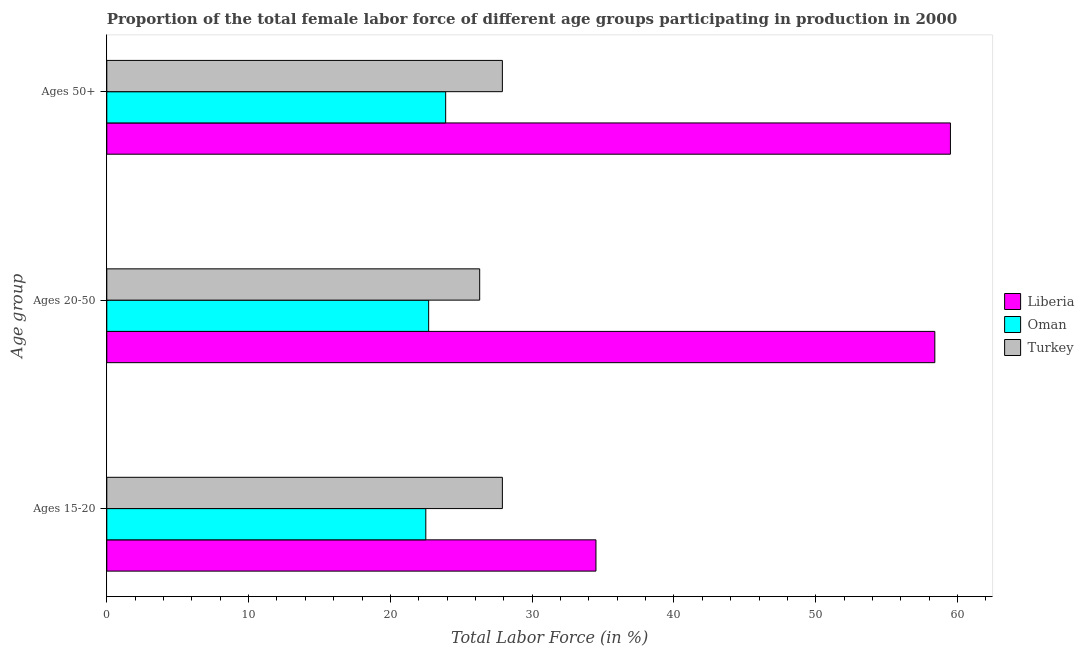How many bars are there on the 3rd tick from the top?
Keep it short and to the point. 3. How many bars are there on the 1st tick from the bottom?
Provide a succinct answer. 3. What is the label of the 3rd group of bars from the top?
Make the answer very short. Ages 15-20. What is the percentage of female labor force within the age group 15-20 in Turkey?
Your answer should be very brief. 27.9. Across all countries, what is the maximum percentage of female labor force within the age group 20-50?
Provide a short and direct response. 58.4. Across all countries, what is the minimum percentage of female labor force above age 50?
Your response must be concise. 23.9. In which country was the percentage of female labor force within the age group 15-20 maximum?
Your response must be concise. Liberia. In which country was the percentage of female labor force above age 50 minimum?
Provide a short and direct response. Oman. What is the total percentage of female labor force above age 50 in the graph?
Ensure brevity in your answer.  111.3. What is the difference between the percentage of female labor force above age 50 in Oman and that in Liberia?
Provide a short and direct response. -35.6. What is the difference between the percentage of female labor force above age 50 in Liberia and the percentage of female labor force within the age group 15-20 in Turkey?
Make the answer very short. 31.6. What is the average percentage of female labor force above age 50 per country?
Offer a terse response. 37.1. What is the difference between the percentage of female labor force above age 50 and percentage of female labor force within the age group 20-50 in Liberia?
Give a very brief answer. 1.1. In how many countries, is the percentage of female labor force within the age group 15-20 greater than 40 %?
Give a very brief answer. 0. What is the ratio of the percentage of female labor force within the age group 15-20 in Liberia to that in Oman?
Provide a succinct answer. 1.53. What is the difference between the highest and the second highest percentage of female labor force above age 50?
Provide a succinct answer. 31.6. What is the difference between the highest and the lowest percentage of female labor force above age 50?
Provide a succinct answer. 35.6. Is the sum of the percentage of female labor force within the age group 15-20 in Turkey and Oman greater than the maximum percentage of female labor force above age 50 across all countries?
Keep it short and to the point. No. What does the 1st bar from the top in Ages 20-50 represents?
Your answer should be compact. Turkey. What does the 2nd bar from the bottom in Ages 20-50 represents?
Give a very brief answer. Oman. How many bars are there?
Your answer should be very brief. 9. How many countries are there in the graph?
Offer a terse response. 3. Does the graph contain any zero values?
Provide a succinct answer. No. Does the graph contain grids?
Make the answer very short. No. What is the title of the graph?
Give a very brief answer. Proportion of the total female labor force of different age groups participating in production in 2000. What is the label or title of the Y-axis?
Give a very brief answer. Age group. What is the Total Labor Force (in %) of Liberia in Ages 15-20?
Make the answer very short. 34.5. What is the Total Labor Force (in %) in Oman in Ages 15-20?
Your answer should be very brief. 22.5. What is the Total Labor Force (in %) in Turkey in Ages 15-20?
Keep it short and to the point. 27.9. What is the Total Labor Force (in %) in Liberia in Ages 20-50?
Ensure brevity in your answer.  58.4. What is the Total Labor Force (in %) of Oman in Ages 20-50?
Your answer should be compact. 22.7. What is the Total Labor Force (in %) of Turkey in Ages 20-50?
Your answer should be compact. 26.3. What is the Total Labor Force (in %) in Liberia in Ages 50+?
Keep it short and to the point. 59.5. What is the Total Labor Force (in %) of Oman in Ages 50+?
Your response must be concise. 23.9. What is the Total Labor Force (in %) of Turkey in Ages 50+?
Your response must be concise. 27.9. Across all Age group, what is the maximum Total Labor Force (in %) in Liberia?
Your response must be concise. 59.5. Across all Age group, what is the maximum Total Labor Force (in %) of Oman?
Your answer should be very brief. 23.9. Across all Age group, what is the maximum Total Labor Force (in %) of Turkey?
Give a very brief answer. 27.9. Across all Age group, what is the minimum Total Labor Force (in %) of Liberia?
Give a very brief answer. 34.5. Across all Age group, what is the minimum Total Labor Force (in %) in Oman?
Offer a terse response. 22.5. Across all Age group, what is the minimum Total Labor Force (in %) in Turkey?
Keep it short and to the point. 26.3. What is the total Total Labor Force (in %) in Liberia in the graph?
Make the answer very short. 152.4. What is the total Total Labor Force (in %) in Oman in the graph?
Offer a very short reply. 69.1. What is the total Total Labor Force (in %) in Turkey in the graph?
Keep it short and to the point. 82.1. What is the difference between the Total Labor Force (in %) in Liberia in Ages 15-20 and that in Ages 20-50?
Offer a very short reply. -23.9. What is the difference between the Total Labor Force (in %) of Oman in Ages 20-50 and that in Ages 50+?
Keep it short and to the point. -1.2. What is the difference between the Total Labor Force (in %) of Liberia in Ages 15-20 and the Total Labor Force (in %) of Oman in Ages 20-50?
Ensure brevity in your answer.  11.8. What is the difference between the Total Labor Force (in %) of Liberia in Ages 15-20 and the Total Labor Force (in %) of Turkey in Ages 20-50?
Keep it short and to the point. 8.2. What is the difference between the Total Labor Force (in %) of Liberia in Ages 15-20 and the Total Labor Force (in %) of Turkey in Ages 50+?
Offer a terse response. 6.6. What is the difference between the Total Labor Force (in %) in Oman in Ages 15-20 and the Total Labor Force (in %) in Turkey in Ages 50+?
Make the answer very short. -5.4. What is the difference between the Total Labor Force (in %) of Liberia in Ages 20-50 and the Total Labor Force (in %) of Oman in Ages 50+?
Your answer should be very brief. 34.5. What is the difference between the Total Labor Force (in %) of Liberia in Ages 20-50 and the Total Labor Force (in %) of Turkey in Ages 50+?
Offer a very short reply. 30.5. What is the average Total Labor Force (in %) in Liberia per Age group?
Make the answer very short. 50.8. What is the average Total Labor Force (in %) in Oman per Age group?
Keep it short and to the point. 23.03. What is the average Total Labor Force (in %) in Turkey per Age group?
Your answer should be very brief. 27.37. What is the difference between the Total Labor Force (in %) in Liberia and Total Labor Force (in %) in Turkey in Ages 15-20?
Ensure brevity in your answer.  6.6. What is the difference between the Total Labor Force (in %) in Oman and Total Labor Force (in %) in Turkey in Ages 15-20?
Your answer should be very brief. -5.4. What is the difference between the Total Labor Force (in %) in Liberia and Total Labor Force (in %) in Oman in Ages 20-50?
Give a very brief answer. 35.7. What is the difference between the Total Labor Force (in %) in Liberia and Total Labor Force (in %) in Turkey in Ages 20-50?
Provide a short and direct response. 32.1. What is the difference between the Total Labor Force (in %) in Oman and Total Labor Force (in %) in Turkey in Ages 20-50?
Keep it short and to the point. -3.6. What is the difference between the Total Labor Force (in %) in Liberia and Total Labor Force (in %) in Oman in Ages 50+?
Your answer should be compact. 35.6. What is the difference between the Total Labor Force (in %) of Liberia and Total Labor Force (in %) of Turkey in Ages 50+?
Keep it short and to the point. 31.6. What is the difference between the Total Labor Force (in %) in Oman and Total Labor Force (in %) in Turkey in Ages 50+?
Your answer should be compact. -4. What is the ratio of the Total Labor Force (in %) of Liberia in Ages 15-20 to that in Ages 20-50?
Give a very brief answer. 0.59. What is the ratio of the Total Labor Force (in %) of Turkey in Ages 15-20 to that in Ages 20-50?
Your answer should be compact. 1.06. What is the ratio of the Total Labor Force (in %) in Liberia in Ages 15-20 to that in Ages 50+?
Your response must be concise. 0.58. What is the ratio of the Total Labor Force (in %) of Oman in Ages 15-20 to that in Ages 50+?
Provide a succinct answer. 0.94. What is the ratio of the Total Labor Force (in %) of Turkey in Ages 15-20 to that in Ages 50+?
Give a very brief answer. 1. What is the ratio of the Total Labor Force (in %) in Liberia in Ages 20-50 to that in Ages 50+?
Ensure brevity in your answer.  0.98. What is the ratio of the Total Labor Force (in %) in Oman in Ages 20-50 to that in Ages 50+?
Give a very brief answer. 0.95. What is the ratio of the Total Labor Force (in %) of Turkey in Ages 20-50 to that in Ages 50+?
Your answer should be very brief. 0.94. What is the difference between the highest and the second highest Total Labor Force (in %) in Oman?
Offer a terse response. 1.2. What is the difference between the highest and the second highest Total Labor Force (in %) in Turkey?
Make the answer very short. 0. What is the difference between the highest and the lowest Total Labor Force (in %) in Liberia?
Keep it short and to the point. 25. What is the difference between the highest and the lowest Total Labor Force (in %) in Turkey?
Give a very brief answer. 1.6. 